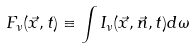<formula> <loc_0><loc_0><loc_500><loc_500>F _ { \nu } ( \vec { x } , t ) \equiv \int I _ { \nu } ( \vec { x } , \vec { n } , t ) d \omega</formula> 